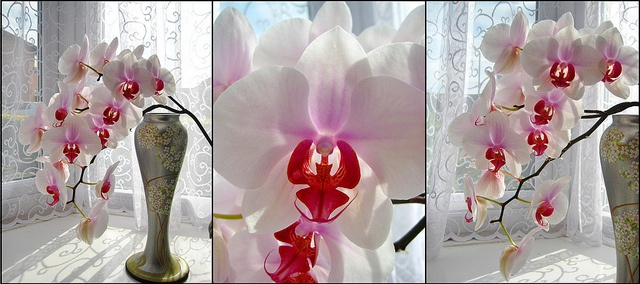Describe the objects in this image and their specific colors. I can see vase in gray, darkgreen, black, and maroon tones and vase in gray and olive tones in this image. 